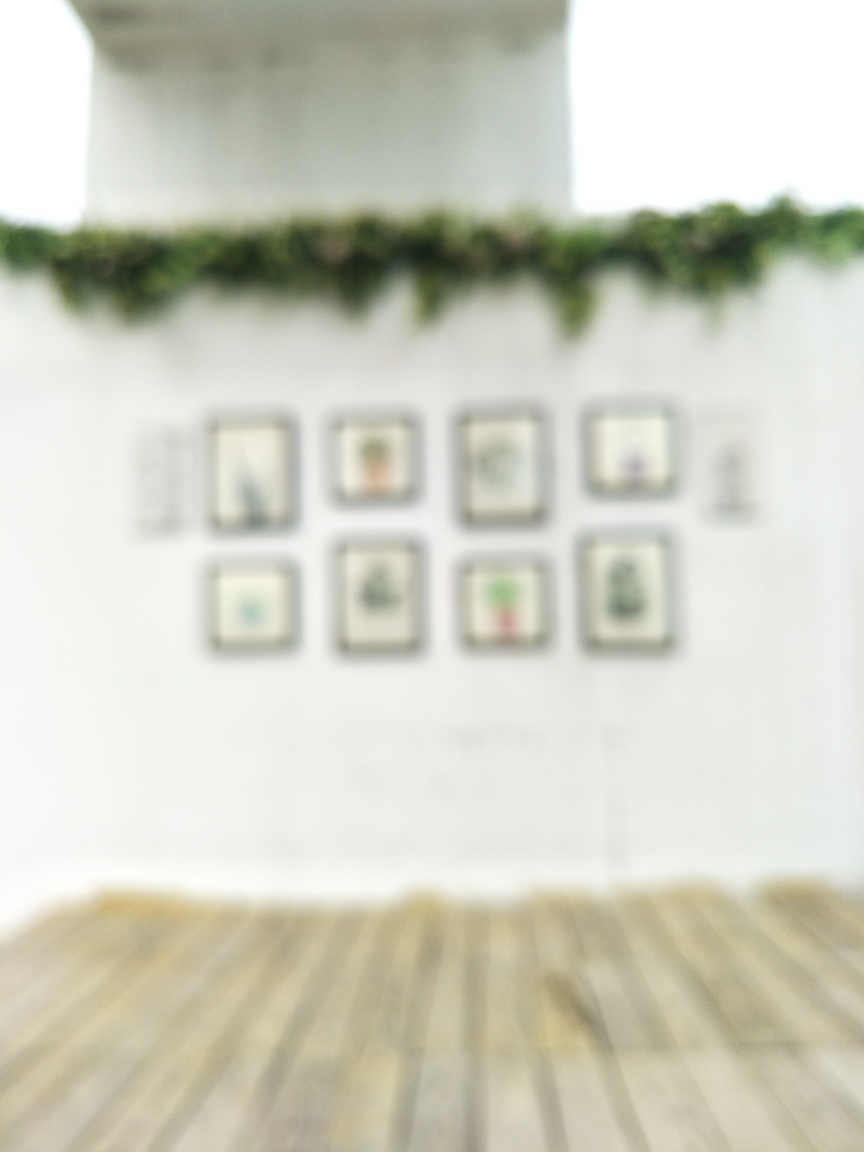Could there be any symbolic meaning behind the decision to blur an image like this? Yes, the use of blurring could symbolize a variety of themes including memory and its imperfections, the passage of time, lost clarity or the idea that not everything in life is meant to be seen clearly. It invites introspection and personal interpretation from the viewer. 